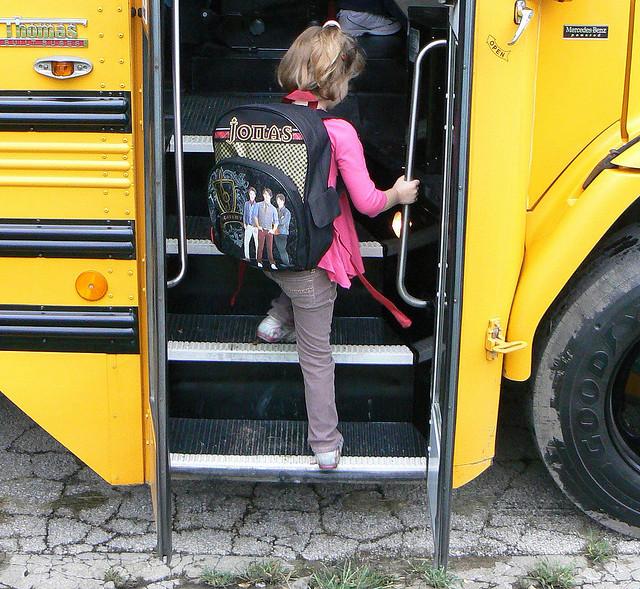Is it raining?
Quick response, please. No. How many steps are there?
Answer briefly. 4. Is this a school activity?
Give a very brief answer. Yes. 